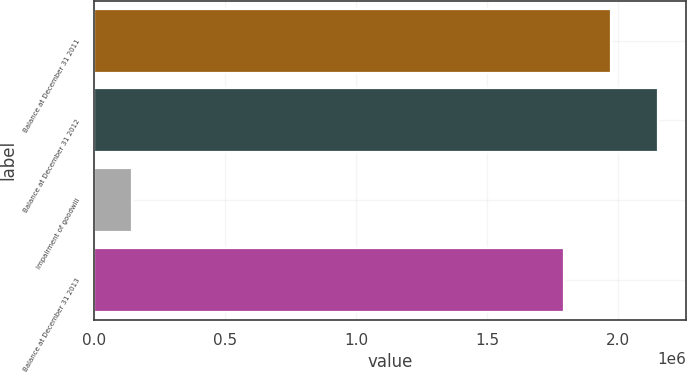<chart> <loc_0><loc_0><loc_500><loc_500><bar_chart><fcel>Balance at December 31 2011<fcel>Balance at December 31 2012<fcel>Impairment of goodwill<fcel>Balance at December 31 2013<nl><fcel>1.97099e+06<fcel>2.15017e+06<fcel>142423<fcel>1.79181e+06<nl></chart> 